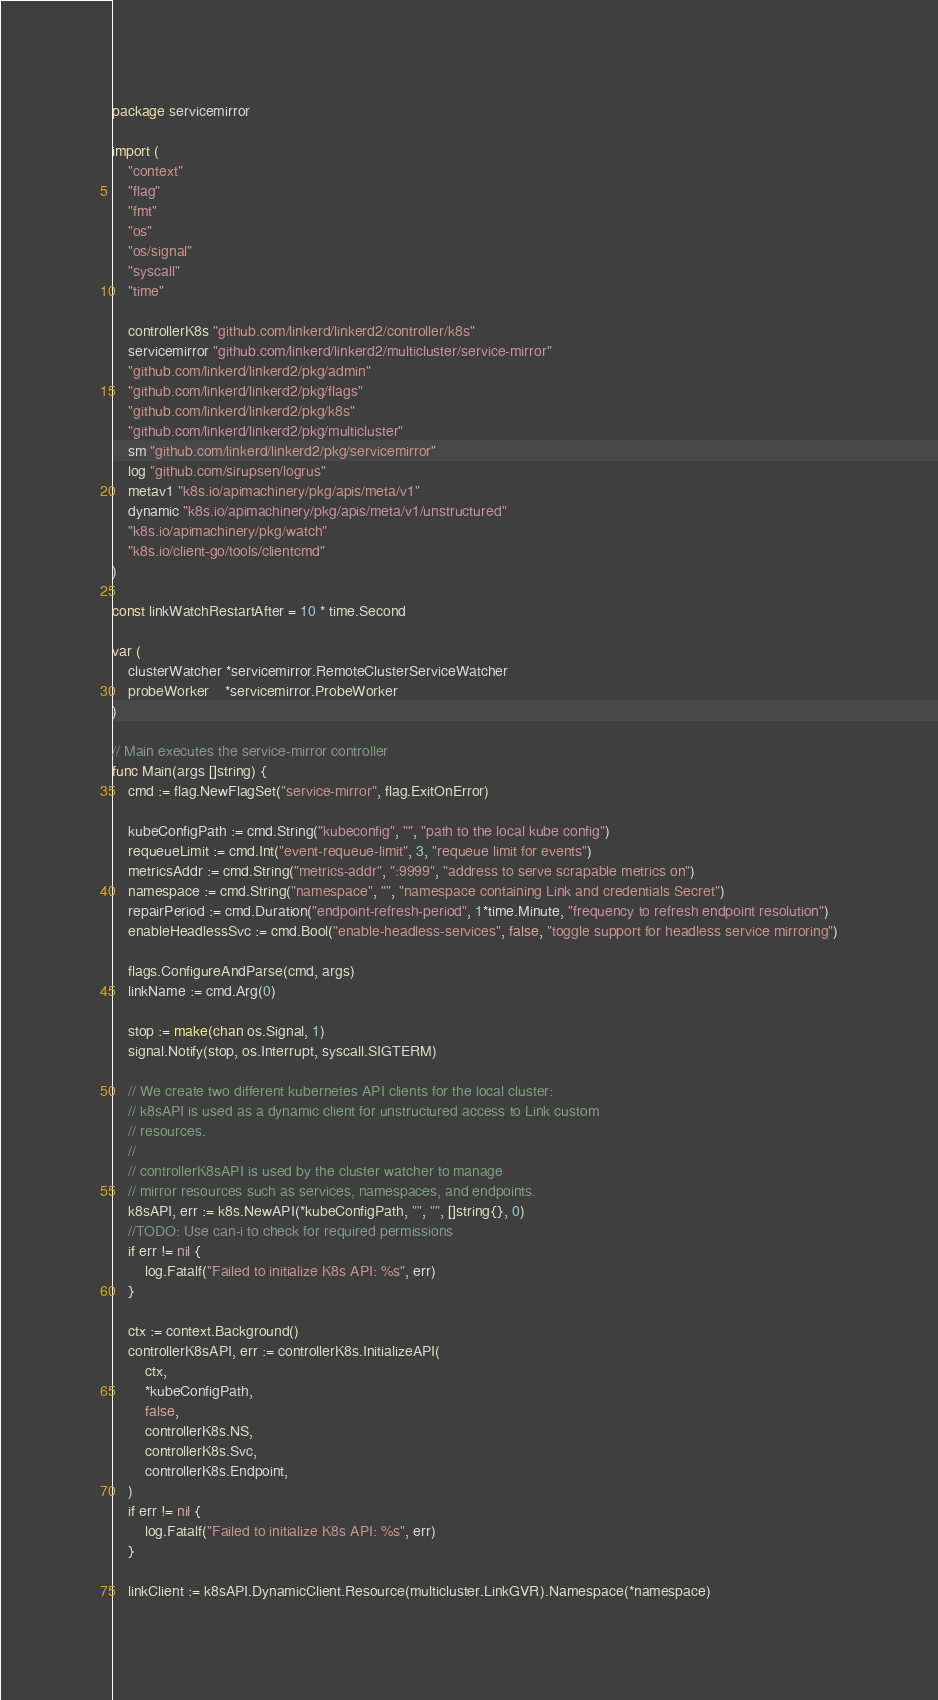<code> <loc_0><loc_0><loc_500><loc_500><_Go_>package servicemirror

import (
	"context"
	"flag"
	"fmt"
	"os"
	"os/signal"
	"syscall"
	"time"

	controllerK8s "github.com/linkerd/linkerd2/controller/k8s"
	servicemirror "github.com/linkerd/linkerd2/multicluster/service-mirror"
	"github.com/linkerd/linkerd2/pkg/admin"
	"github.com/linkerd/linkerd2/pkg/flags"
	"github.com/linkerd/linkerd2/pkg/k8s"
	"github.com/linkerd/linkerd2/pkg/multicluster"
	sm "github.com/linkerd/linkerd2/pkg/servicemirror"
	log "github.com/sirupsen/logrus"
	metav1 "k8s.io/apimachinery/pkg/apis/meta/v1"
	dynamic "k8s.io/apimachinery/pkg/apis/meta/v1/unstructured"
	"k8s.io/apimachinery/pkg/watch"
	"k8s.io/client-go/tools/clientcmd"
)

const linkWatchRestartAfter = 10 * time.Second

var (
	clusterWatcher *servicemirror.RemoteClusterServiceWatcher
	probeWorker    *servicemirror.ProbeWorker
)

// Main executes the service-mirror controller
func Main(args []string) {
	cmd := flag.NewFlagSet("service-mirror", flag.ExitOnError)

	kubeConfigPath := cmd.String("kubeconfig", "", "path to the local kube config")
	requeueLimit := cmd.Int("event-requeue-limit", 3, "requeue limit for events")
	metricsAddr := cmd.String("metrics-addr", ":9999", "address to serve scrapable metrics on")
	namespace := cmd.String("namespace", "", "namespace containing Link and credentials Secret")
	repairPeriod := cmd.Duration("endpoint-refresh-period", 1*time.Minute, "frequency to refresh endpoint resolution")
	enableHeadlessSvc := cmd.Bool("enable-headless-services", false, "toggle support for headless service mirroring")

	flags.ConfigureAndParse(cmd, args)
	linkName := cmd.Arg(0)

	stop := make(chan os.Signal, 1)
	signal.Notify(stop, os.Interrupt, syscall.SIGTERM)

	// We create two different kubernetes API clients for the local cluster:
	// k8sAPI is used as a dynamic client for unstructured access to Link custom
	// resources.
	//
	// controllerK8sAPI is used by the cluster watcher to manage
	// mirror resources such as services, namespaces, and endpoints.
	k8sAPI, err := k8s.NewAPI(*kubeConfigPath, "", "", []string{}, 0)
	//TODO: Use can-i to check for required permissions
	if err != nil {
		log.Fatalf("Failed to initialize K8s API: %s", err)
	}

	ctx := context.Background()
	controllerK8sAPI, err := controllerK8s.InitializeAPI(
		ctx,
		*kubeConfigPath,
		false,
		controllerK8s.NS,
		controllerK8s.Svc,
		controllerK8s.Endpoint,
	)
	if err != nil {
		log.Fatalf("Failed to initialize K8s API: %s", err)
	}

	linkClient := k8sAPI.DynamicClient.Resource(multicluster.LinkGVR).Namespace(*namespace)
</code> 